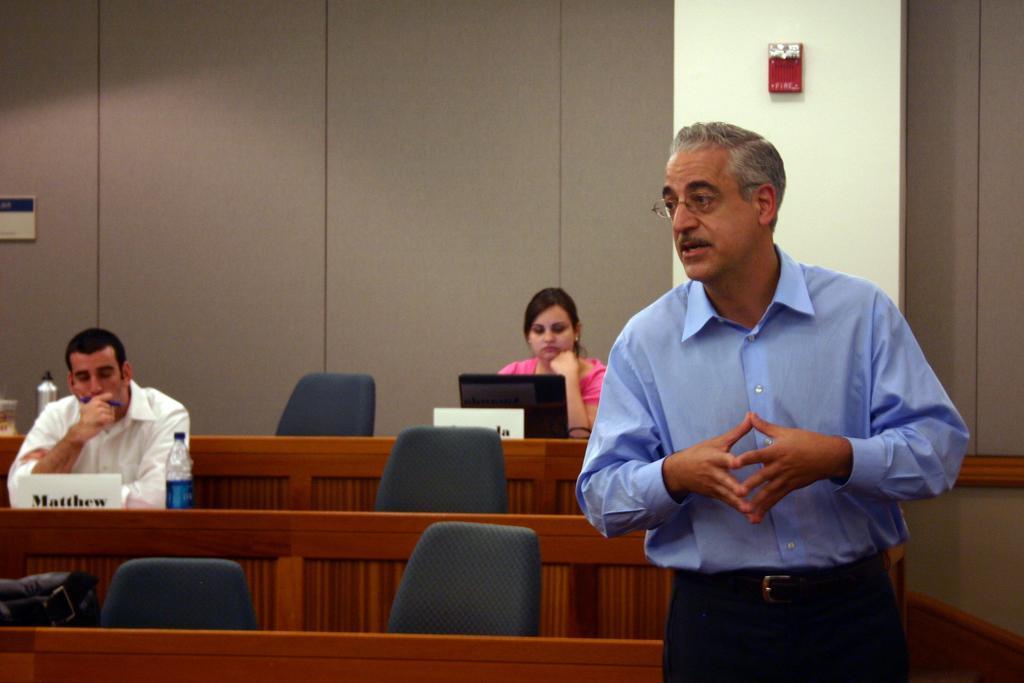In one or two sentences, can you explain what this image depicts? In this image we can see a man and a woman sitting on the chairs. Here we can see a man is standing. There are chairs, bottles, tables, name boards, and a laptop. In the background we can see wall, pillar, and other objects. 